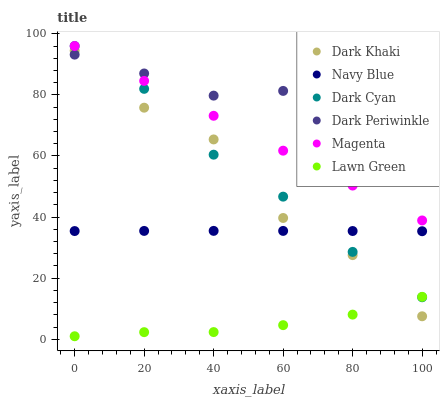Does Lawn Green have the minimum area under the curve?
Answer yes or no. Yes. Does Dark Periwinkle have the maximum area under the curve?
Answer yes or no. Yes. Does Navy Blue have the minimum area under the curve?
Answer yes or no. No. Does Navy Blue have the maximum area under the curve?
Answer yes or no. No. Is Magenta the smoothest?
Answer yes or no. Yes. Is Dark Khaki the roughest?
Answer yes or no. Yes. Is Navy Blue the smoothest?
Answer yes or no. No. Is Navy Blue the roughest?
Answer yes or no. No. Does Lawn Green have the lowest value?
Answer yes or no. Yes. Does Navy Blue have the lowest value?
Answer yes or no. No. Does Magenta have the highest value?
Answer yes or no. Yes. Does Navy Blue have the highest value?
Answer yes or no. No. Is Navy Blue less than Dark Periwinkle?
Answer yes or no. Yes. Is Magenta greater than Lawn Green?
Answer yes or no. Yes. Does Magenta intersect Dark Periwinkle?
Answer yes or no. Yes. Is Magenta less than Dark Periwinkle?
Answer yes or no. No. Is Magenta greater than Dark Periwinkle?
Answer yes or no. No. Does Navy Blue intersect Dark Periwinkle?
Answer yes or no. No. 